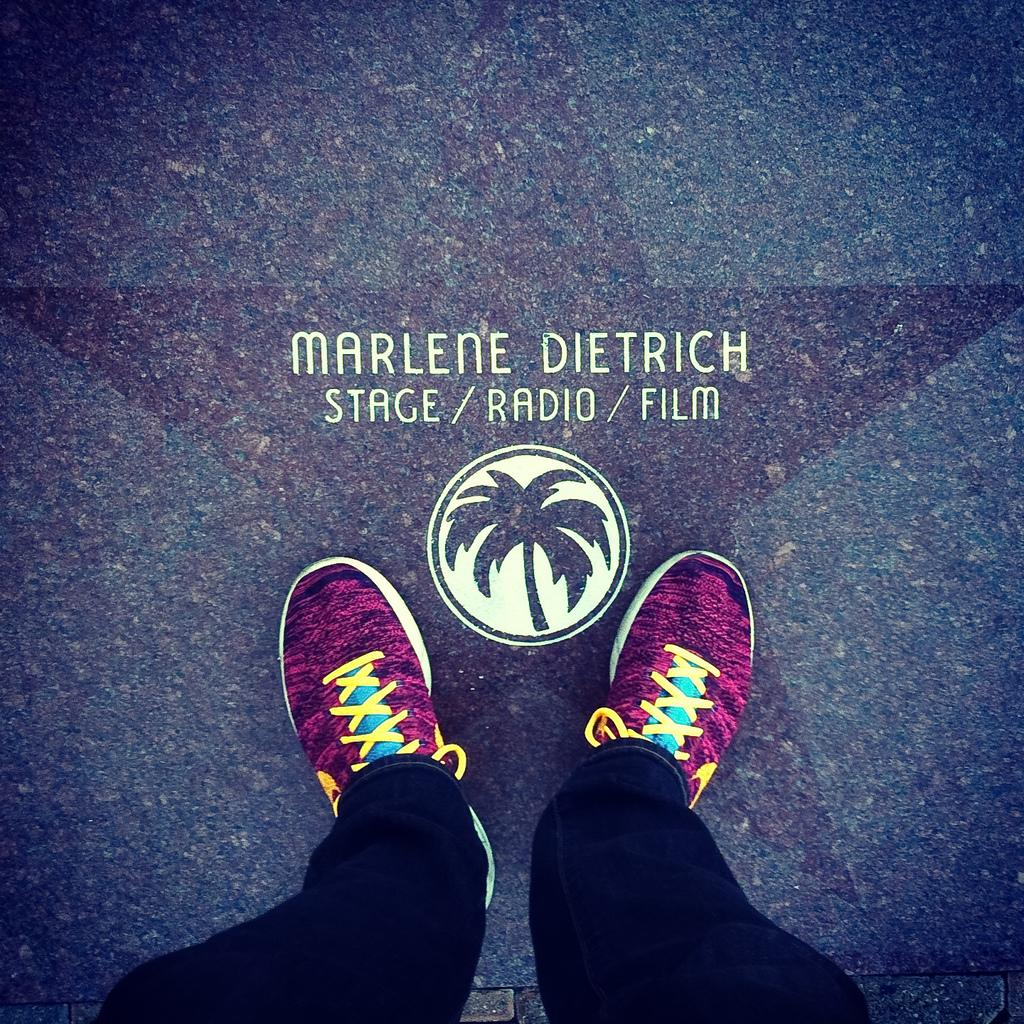Who or what is present in the image? There is in the image. What type of shoes is the person wearing? The person is wearing pink shoes. What part of the person's body is visible in the image? The person's legs are visible in the image. What is the ground like in the image? The ground has a star symbol and a coconut logo, and there is some text on the ground. What letter does the person's son write on the ground in the image? There is no mention of a son or any letter-writing activity in the image. 